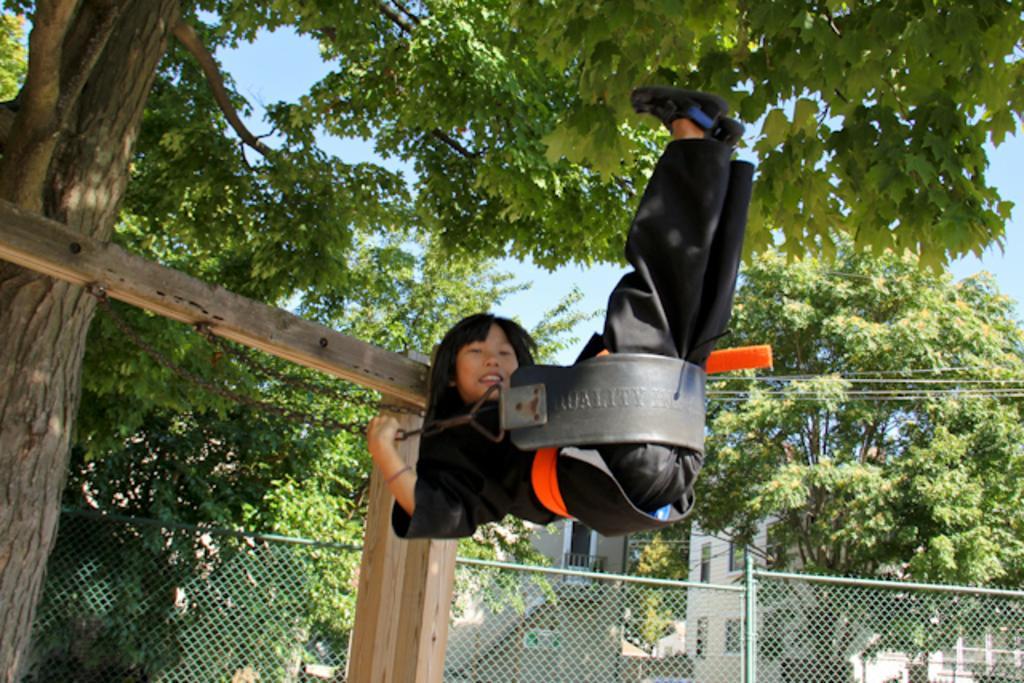How would you summarize this image in a sentence or two? In this picture, there is a girl swinging. She is wearing black clothes. This swing is attached to the wooden poles. At the bottom, there is a fence. In the background, there are trees and sky. 